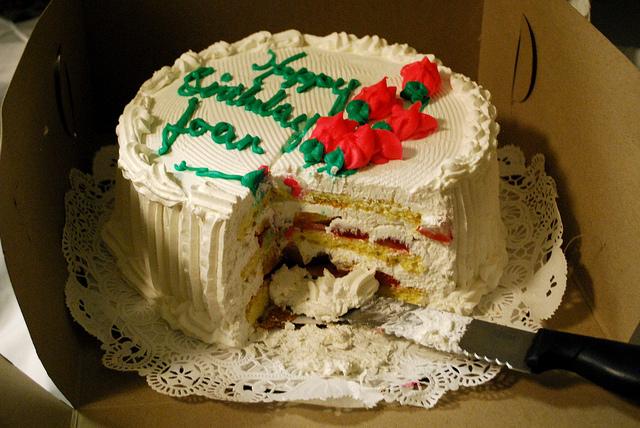What color is the inside of the cake?
Write a very short answer. White. What is the name on this cake?
Short answer required. Joan. How many layers is the cake made of?
Be succinct. 3. 